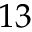Convert formula to latex. <formula><loc_0><loc_0><loc_500><loc_500>1 3</formula> 